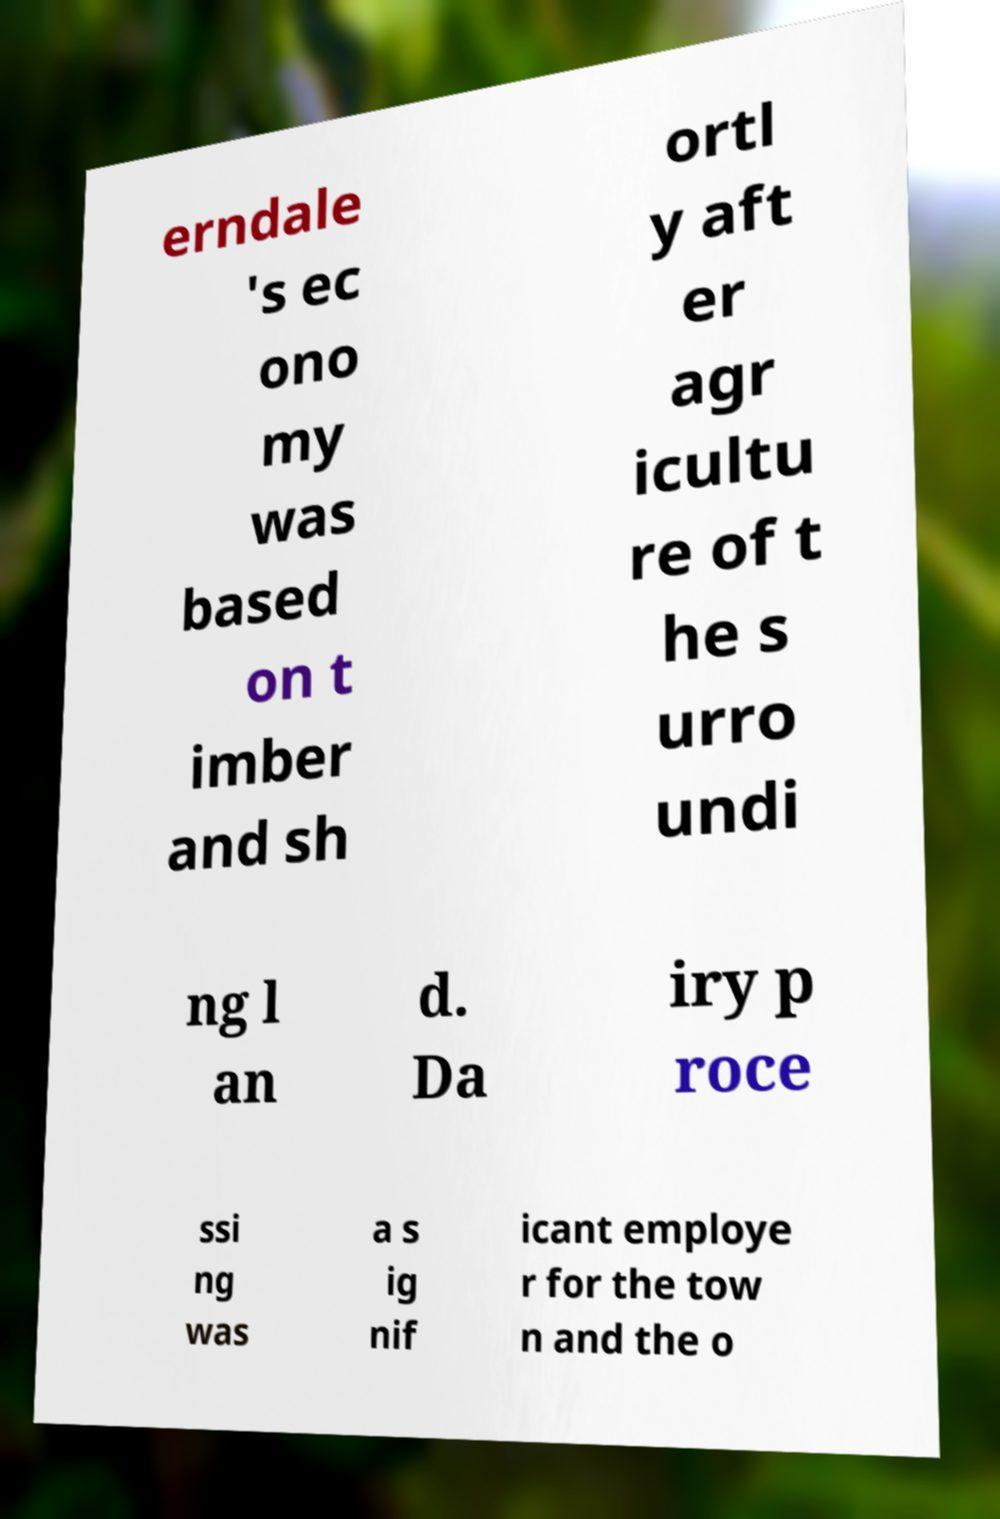For documentation purposes, I need the text within this image transcribed. Could you provide that? erndale 's ec ono my was based on t imber and sh ortl y aft er agr icultu re of t he s urro undi ng l an d. Da iry p roce ssi ng was a s ig nif icant employe r for the tow n and the o 